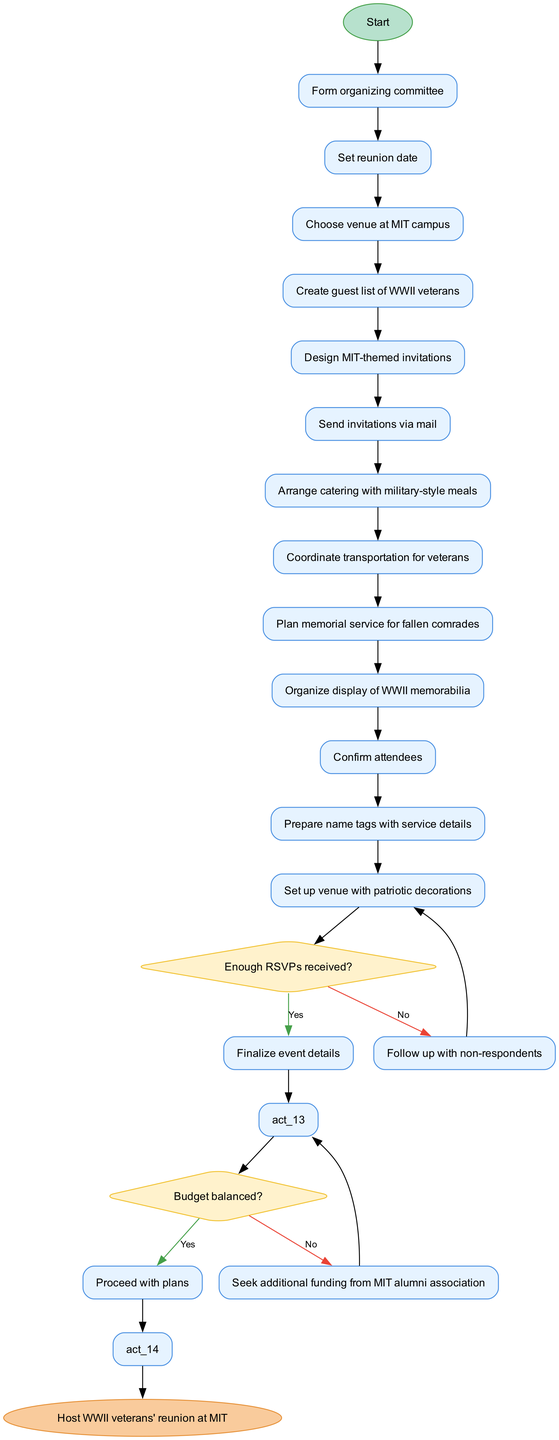What is the first activity in the diagram? The first activity initiated after starting the planning process is "Form organizing committee". It is the first node listed under the activities section, connected directly to the start node.
Answer: Form organizing committee How many decisions are included in the diagram? The diagram contains two decisions. This is determined by counting the decision nodes labeled "Enough RSVPs received?" and "Budget balanced?" within the decisions section.
Answer: 2 What is the final step in the process? The final step in the process is "Host WWII veterans' reunion at MIT". It is the end node of the diagram, indicating the conclusion of the activities outlined.
Answer: Host WWII veterans' reunion at MIT What follows after "Send invitations via mail"? After "Send invitations via mail", there is a decision node titled "Enough RSVPs received?". This connection indicates a branching point based on the responses received from the invitations sent.
Answer: Enough RSVPs received? What happens if the budget is not balanced? If the budget is not balanced, the action taken is "Seek additional funding from MIT alumni association". This is the response when the evaluation of the budget decision node returns a "No".
Answer: Seek additional funding from MIT alumni association How many activities are listed before the first decision node? There are eleven activities listed before the first decision node. Counting from "Form organizing committee" to "Organize display of WWII memorabilia" gives a total of eleven activities in that sequence.
Answer: 11 What is the purpose of the diamond-shaped nodes? The diamond-shaped nodes serve as decision points, requiring evaluation of conditions related to RSVPs and budget status. These nodes indicate important points where the flow of the process can change based on the answers.
Answer: Decision points What is the nature of the last activity before the end node? The last activity before the end node is "Set up venue with patriotic decorations". This is the final preparatory action completed before hosting the reunion event, linking directly to the end of the process.
Answer: Set up venue with patriotic decorations 